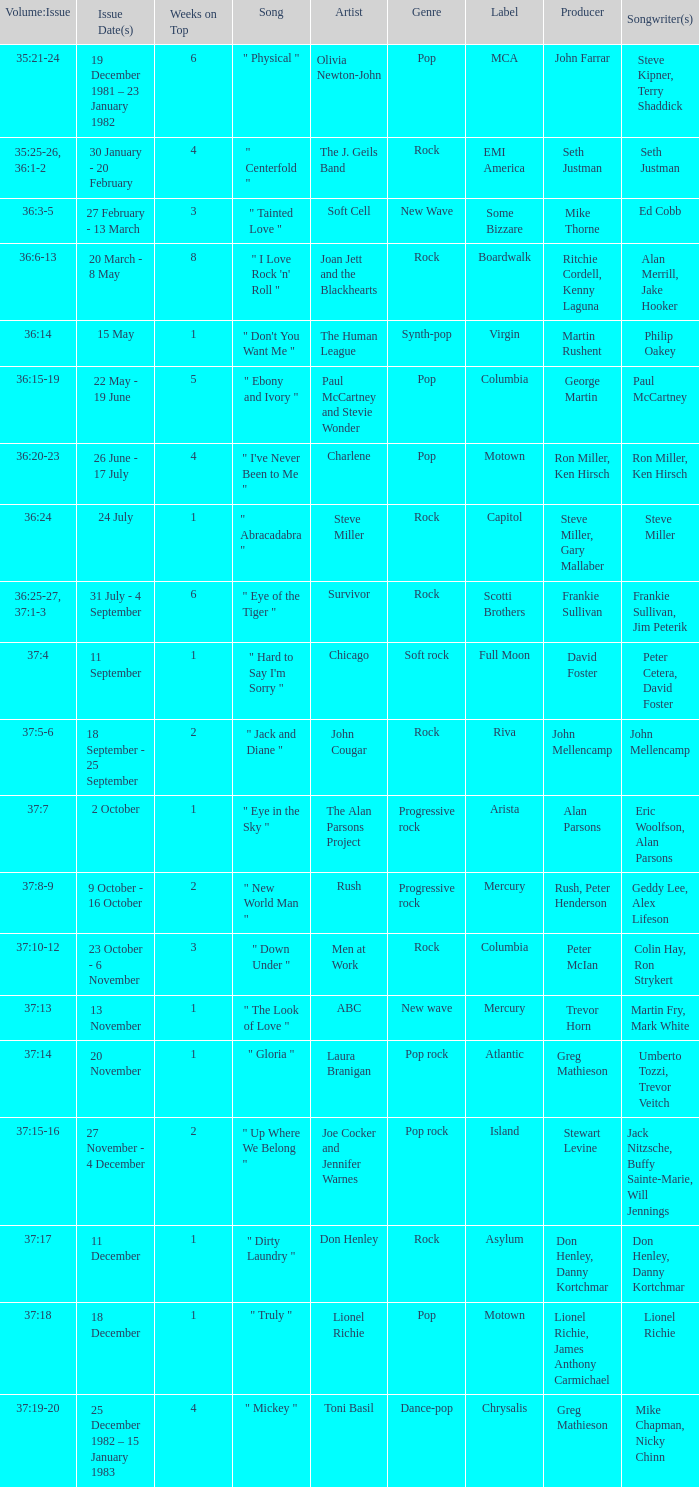Which Issue Date(s) has an Artist of men at work? 23 October - 6 November. 